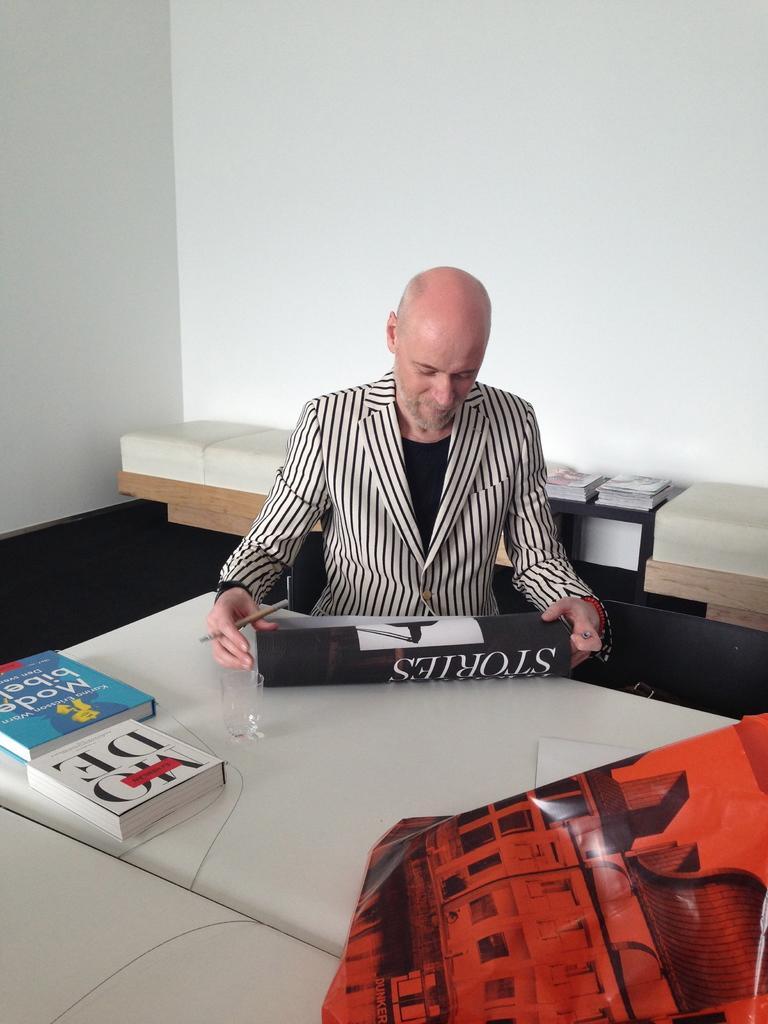How would you summarize this image in a sentence or two? As we can see in the image there is a white color wall, a table and a man sitting over here. On table there is a bag and books. 